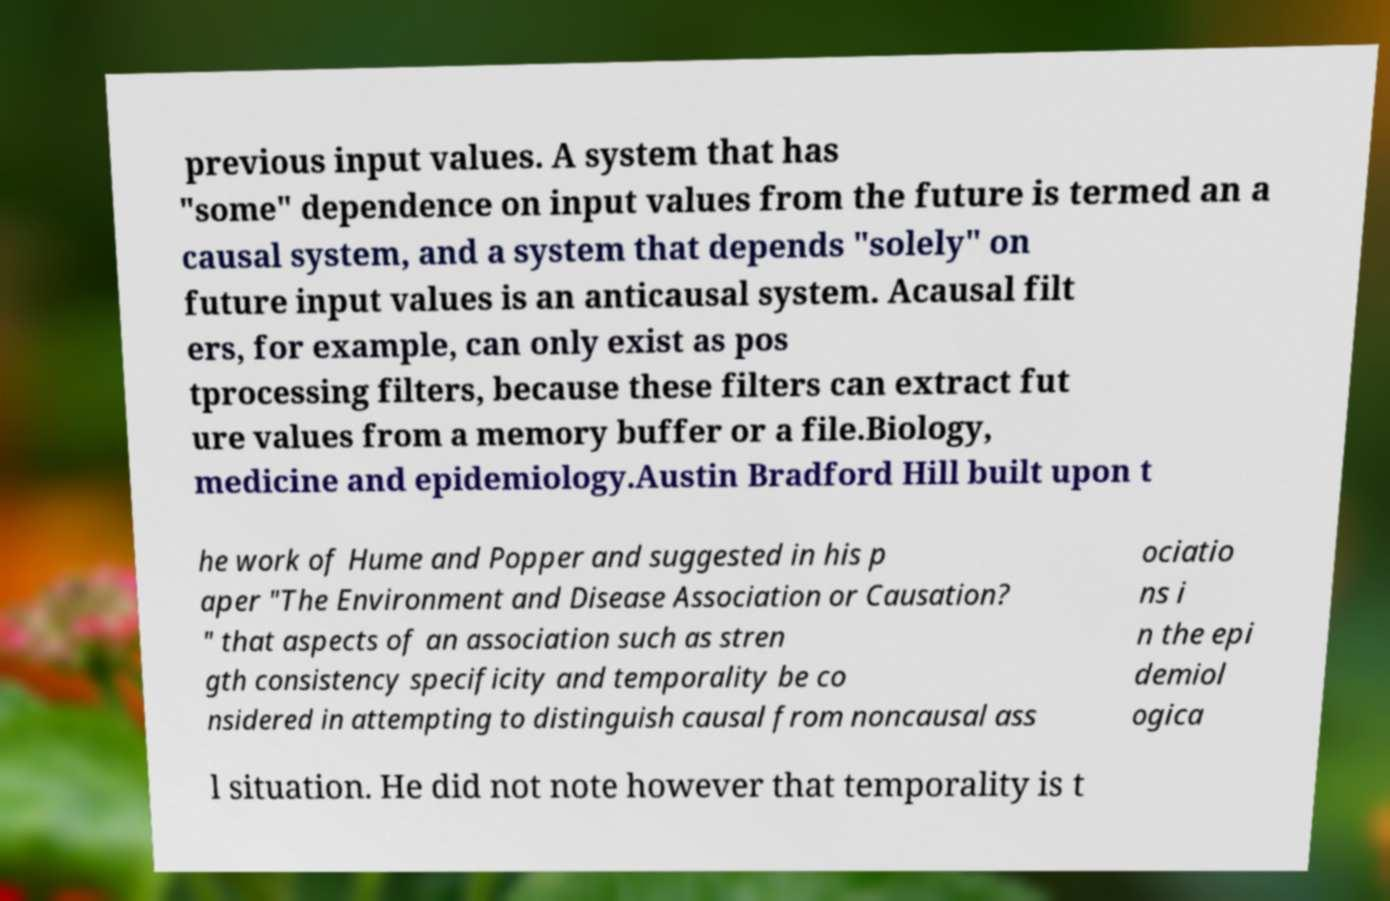What messages or text are displayed in this image? I need them in a readable, typed format. previous input values. A system that has "some" dependence on input values from the future is termed an a causal system, and a system that depends "solely" on future input values is an anticausal system. Acausal filt ers, for example, can only exist as pos tprocessing filters, because these filters can extract fut ure values from a memory buffer or a file.Biology, medicine and epidemiology.Austin Bradford Hill built upon t he work of Hume and Popper and suggested in his p aper "The Environment and Disease Association or Causation? " that aspects of an association such as stren gth consistency specificity and temporality be co nsidered in attempting to distinguish causal from noncausal ass ociatio ns i n the epi demiol ogica l situation. He did not note however that temporality is t 